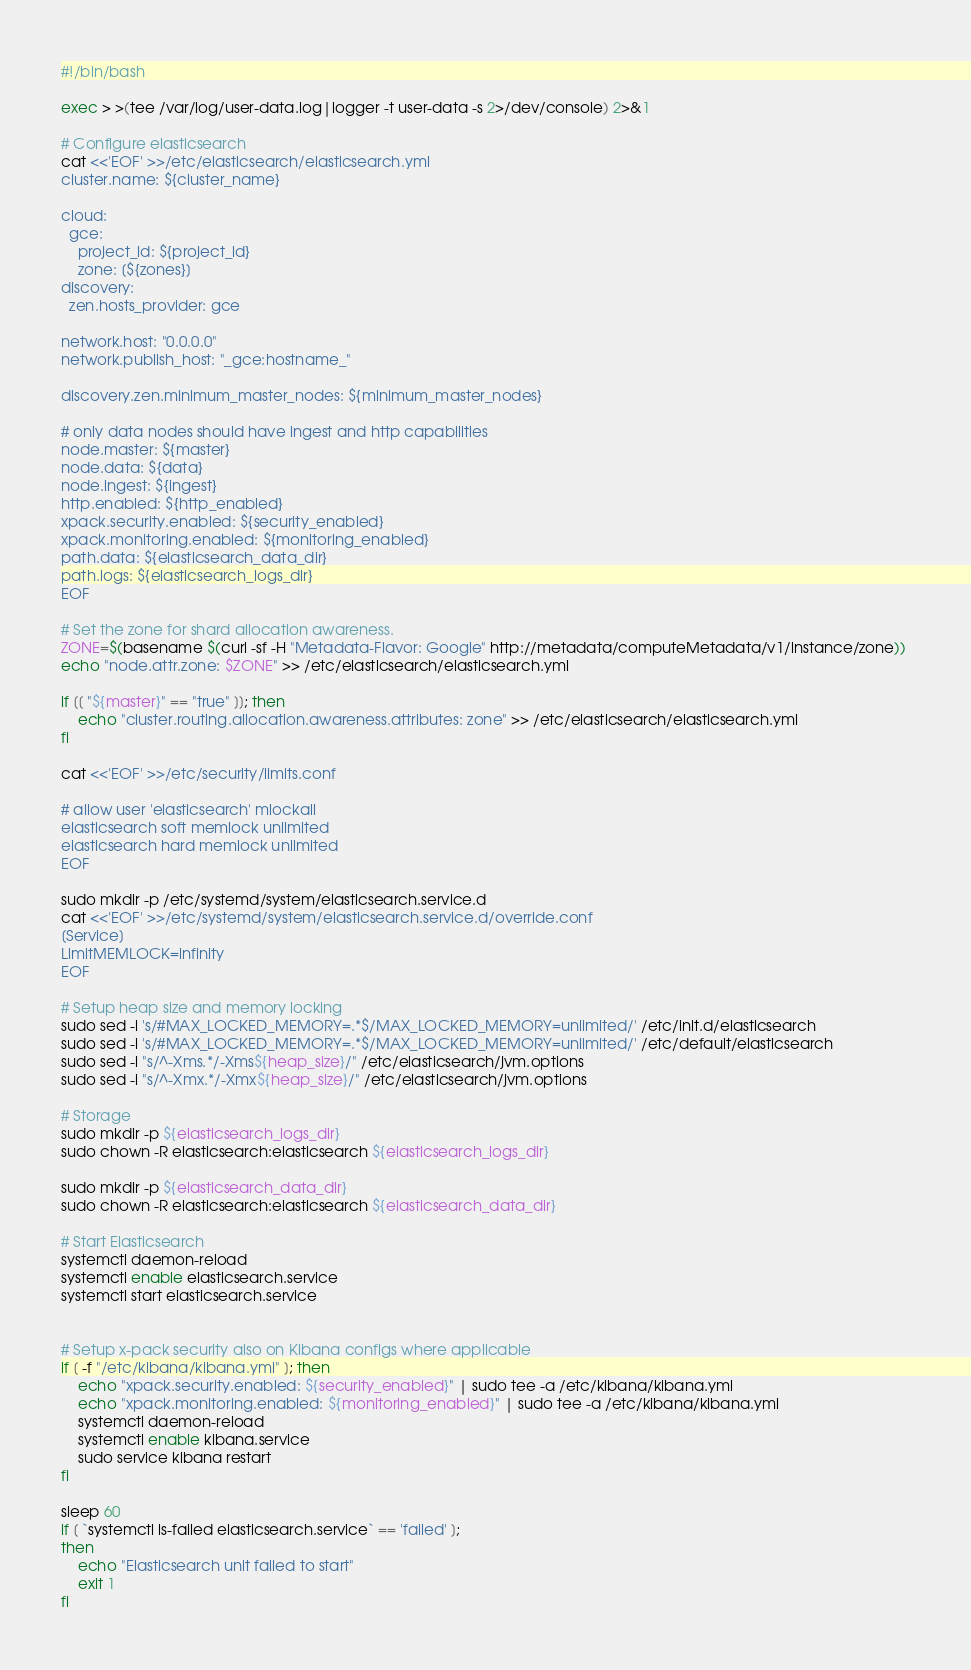Convert code to text. <code><loc_0><loc_0><loc_500><loc_500><_Bash_>#!/bin/bash

exec > >(tee /var/log/user-data.log|logger -t user-data -s 2>/dev/console) 2>&1

# Configure elasticsearch
cat <<'EOF' >>/etc/elasticsearch/elasticsearch.yml
cluster.name: ${cluster_name}

cloud:
  gce:
    project_id: ${project_id}
    zone: [${zones}]
discovery:
  zen.hosts_provider: gce
  
network.host: "0.0.0.0"
network.publish_host: "_gce:hostname_"

discovery.zen.minimum_master_nodes: ${minimum_master_nodes}

# only data nodes should have ingest and http capabilities
node.master: ${master}
node.data: ${data}
node.ingest: ${ingest}
http.enabled: ${http_enabled}
xpack.security.enabled: ${security_enabled}
xpack.monitoring.enabled: ${monitoring_enabled}
path.data: ${elasticsearch_data_dir}
path.logs: ${elasticsearch_logs_dir}
EOF

# Set the zone for shard allocation awareness.
ZONE=$(basename $(curl -sf -H "Metadata-Flavor: Google" http://metadata/computeMetadata/v1/instance/zone)) 
echo "node.attr.zone: $ZONE" >> /etc/elasticsearch/elasticsearch.yml

if [[ "${master}" == "true" ]]; then
    echo "cluster.routing.allocation.awareness.attributes: zone" >> /etc/elasticsearch/elasticsearch.yml
fi

cat <<'EOF' >>/etc/security/limits.conf

# allow user 'elasticsearch' mlockall
elasticsearch soft memlock unlimited
elasticsearch hard memlock unlimited
EOF

sudo mkdir -p /etc/systemd/system/elasticsearch.service.d
cat <<'EOF' >>/etc/systemd/system/elasticsearch.service.d/override.conf
[Service]
LimitMEMLOCK=infinity
EOF

# Setup heap size and memory locking
sudo sed -i 's/#MAX_LOCKED_MEMORY=.*$/MAX_LOCKED_MEMORY=unlimited/' /etc/init.d/elasticsearch
sudo sed -i 's/#MAX_LOCKED_MEMORY=.*$/MAX_LOCKED_MEMORY=unlimited/' /etc/default/elasticsearch
sudo sed -i "s/^-Xms.*/-Xms${heap_size}/" /etc/elasticsearch/jvm.options
sudo sed -i "s/^-Xmx.*/-Xmx${heap_size}/" /etc/elasticsearch/jvm.options

# Storage
sudo mkdir -p ${elasticsearch_logs_dir}
sudo chown -R elasticsearch:elasticsearch ${elasticsearch_logs_dir}

sudo mkdir -p ${elasticsearch_data_dir}
sudo chown -R elasticsearch:elasticsearch ${elasticsearch_data_dir}

# Start Elasticsearch
systemctl daemon-reload
systemctl enable elasticsearch.service
systemctl start elasticsearch.service


# Setup x-pack security also on Kibana configs where applicable
if [ -f "/etc/kibana/kibana.yml" ]; then
    echo "xpack.security.enabled: ${security_enabled}" | sudo tee -a /etc/kibana/kibana.yml
    echo "xpack.monitoring.enabled: ${monitoring_enabled}" | sudo tee -a /etc/kibana/kibana.yml
    systemctl daemon-reload
    systemctl enable kibana.service
    sudo service kibana restart
fi

sleep 60
if [ `systemctl is-failed elasticsearch.service` == 'failed' ];
then
    echo "Elasticsearch unit failed to start"
    exit 1
fi</code> 